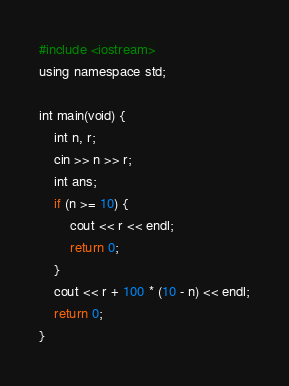Convert code to text. <code><loc_0><loc_0><loc_500><loc_500><_Python_>#include <iostream>
using namespace std;

int main(void) {
    int n, r;
    cin >> n >> r;
    int ans;
    if (n >= 10) {
        cout << r << endl;
        return 0;
    }
    cout << r + 100 * (10 - n) << endl;
    return 0;
}</code> 